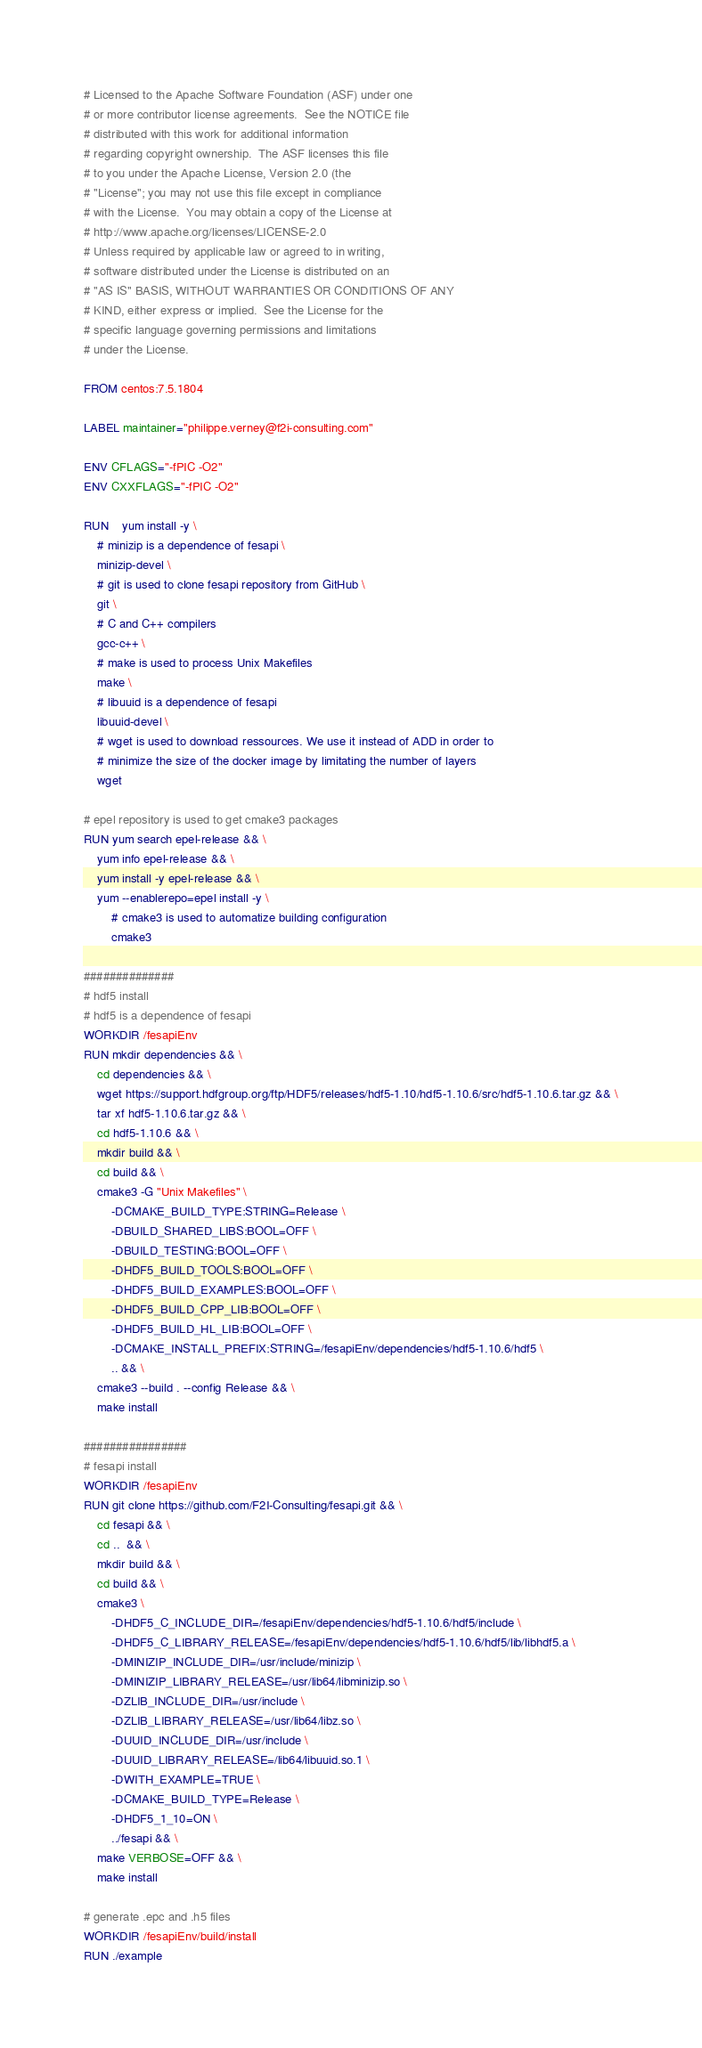Convert code to text. <code><loc_0><loc_0><loc_500><loc_500><_Dockerfile_># Licensed to the Apache Software Foundation (ASF) under one
# or more contributor license agreements.  See the NOTICE file
# distributed with this work for additional information
# regarding copyright ownership.  The ASF licenses this file
# to you under the Apache License, Version 2.0 (the
# "License"; you may not use this file except in compliance
# with the License.  You may obtain a copy of the License at
# http://www.apache.org/licenses/LICENSE-2.0
# Unless required by applicable law or agreed to in writing,
# software distributed under the License is distributed on an
# "AS IS" BASIS, WITHOUT WARRANTIES OR CONDITIONS OF ANY
# KIND, either express or implied.  See the License for the
# specific language governing permissions and limitations
# under the License.

FROM centos:7.5.1804

LABEL maintainer="philippe.verney@f2i-consulting.com"

ENV CFLAGS="-fPIC -O2"
ENV CXXFLAGS="-fPIC -O2"

RUN	yum install -y \
	# minizip is a dependence of fesapi \ 
	minizip-devel \ 	
	# git is used to clone fesapi repository from GitHub \	
	git \				
	# C and C++ compilers
	gcc-c++ \		
	# make is used to process Unix Makefiles
	make \				
	# libuuid is a dependence of fesapi
	libuuid-devel \
	# wget is used to download ressources. We use it instead of ADD in order to
	# minimize the size of the docker image by limitating the number of layers
	wget 
	
# epel repository is used to get cmake3 packages
RUN yum search epel-release && \
	yum info epel-release && \
	yum install -y epel-release && \
	yum --enablerepo=epel install -y \
		# cmake3 is used to automatize building configuration
		cmake3

##############
# hdf5 install
# hdf5 is a dependence of fesapi
WORKDIR /fesapiEnv
RUN mkdir dependencies && \
	cd dependencies && \
	wget https://support.hdfgroup.org/ftp/HDF5/releases/hdf5-1.10/hdf5-1.10.6/src/hdf5-1.10.6.tar.gz && \
	tar xf hdf5-1.10.6.tar.gz && \
	cd hdf5-1.10.6 && \
	mkdir build && \
	cd build && \
	cmake3 -G "Unix Makefiles" \
		-DCMAKE_BUILD_TYPE:STRING=Release \
		-DBUILD_SHARED_LIBS:BOOL=OFF \
		-DBUILD_TESTING:BOOL=OFF \
		-DHDF5_BUILD_TOOLS:BOOL=OFF \
		-DHDF5_BUILD_EXAMPLES:BOOL=OFF \
		-DHDF5_BUILD_CPP_LIB:BOOL=OFF \
		-DHDF5_BUILD_HL_LIB:BOOL=OFF \
		-DCMAKE_INSTALL_PREFIX:STRING=/fesapiEnv/dependencies/hdf5-1.10.6/hdf5 \
		.. && \
	cmake3 --build . --config Release && \	
	make install 

################
# fesapi install
WORKDIR /fesapiEnv
RUN git clone https://github.com/F2I-Consulting/fesapi.git && \
	cd fesapi && \
	cd ..  && \
	mkdir build && \
	cd build && \
	cmake3 \
		-DHDF5_C_INCLUDE_DIR=/fesapiEnv/dependencies/hdf5-1.10.6/hdf5/include \
		-DHDF5_C_LIBRARY_RELEASE=/fesapiEnv/dependencies/hdf5-1.10.6/hdf5/lib/libhdf5.a \
		-DMINIZIP_INCLUDE_DIR=/usr/include/minizip \
		-DMINIZIP_LIBRARY_RELEASE=/usr/lib64/libminizip.so \
		-DZLIB_INCLUDE_DIR=/usr/include \
		-DZLIB_LIBRARY_RELEASE=/usr/lib64/libz.so \
		-DUUID_INCLUDE_DIR=/usr/include \
		-DUUID_LIBRARY_RELEASE=/lib64/libuuid.so.1 \
		-DWITH_EXAMPLE=TRUE \
		-DCMAKE_BUILD_TYPE=Release \
		-DHDF5_1_10=ON \
		../fesapi && \
	make VERBOSE=OFF && \
	make install

# generate .epc and .h5 files
WORKDIR /fesapiEnv/build/install
RUN ./example
</code> 